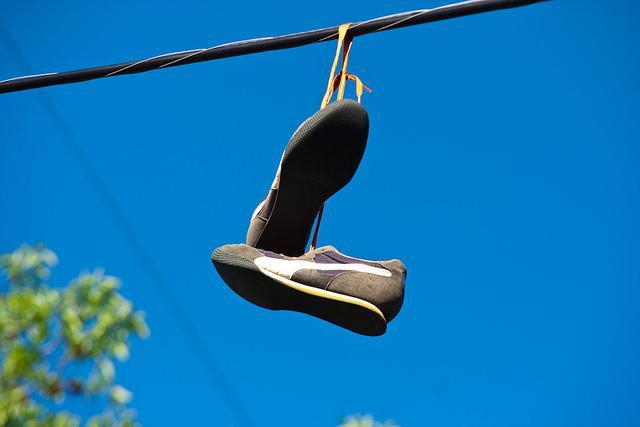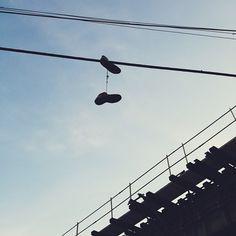The first image is the image on the left, the second image is the image on the right. For the images displayed, is the sentence "One of the images shows multiple pairs of shoes hanging from a power line." factually correct? Answer yes or no. No. The first image is the image on the left, the second image is the image on the right. Analyze the images presented: Is the assertion "There are more than 3 pairs of shoes hanging from an electric wire." valid? Answer yes or no. No. 